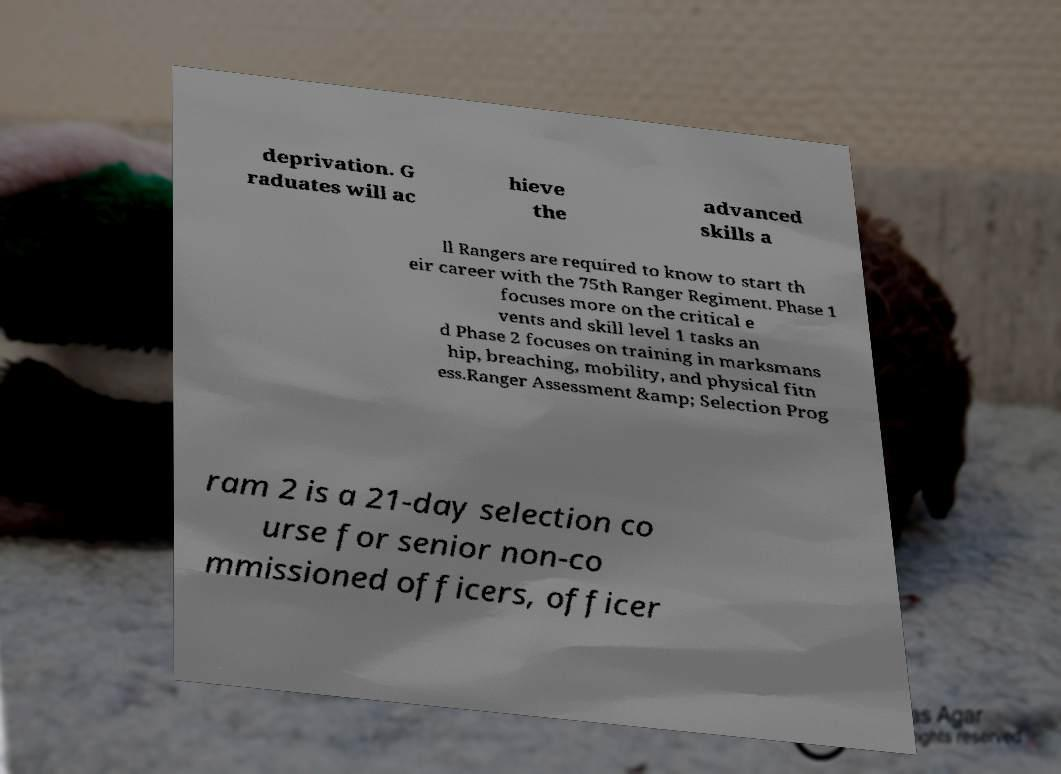For documentation purposes, I need the text within this image transcribed. Could you provide that? deprivation. G raduates will ac hieve the advanced skills a ll Rangers are required to know to start th eir career with the 75th Ranger Regiment. Phase 1 focuses more on the critical e vents and skill level 1 tasks an d Phase 2 focuses on training in marksmans hip, breaching, mobility, and physical fitn ess.Ranger Assessment &amp; Selection Prog ram 2 is a 21-day selection co urse for senior non-co mmissioned officers, officer 